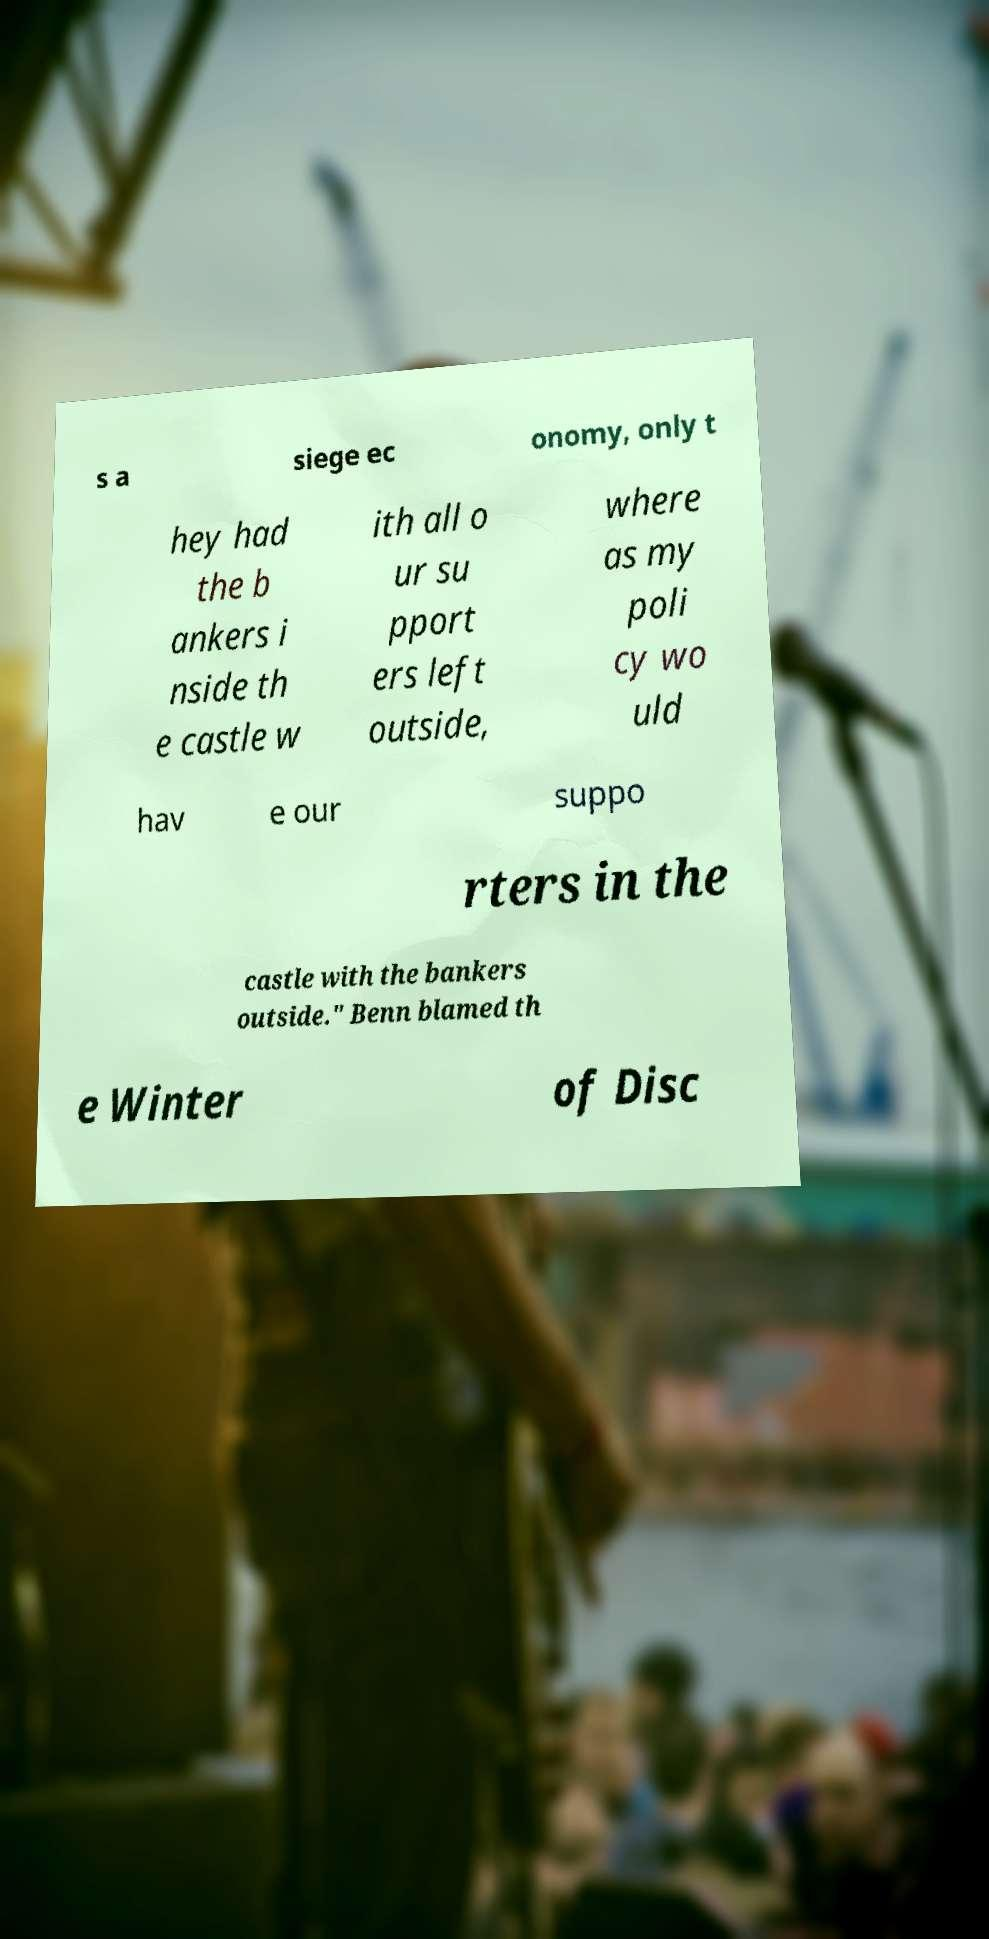What messages or text are displayed in this image? I need them in a readable, typed format. s a siege ec onomy, only t hey had the b ankers i nside th e castle w ith all o ur su pport ers left outside, where as my poli cy wo uld hav e our suppo rters in the castle with the bankers outside." Benn blamed th e Winter of Disc 